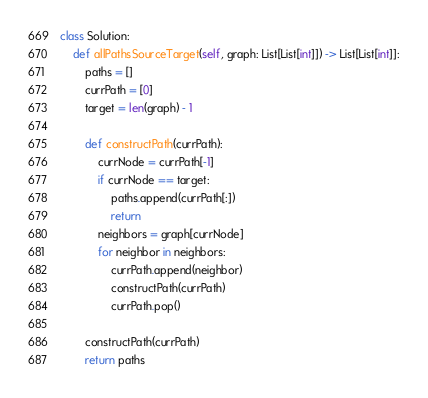Convert code to text. <code><loc_0><loc_0><loc_500><loc_500><_Python_>class Solution:
    def allPathsSourceTarget(self, graph: List[List[int]]) -> List[List[int]]:
        paths = []
        currPath = [0]
        target = len(graph) - 1
        
        def constructPath(currPath):
            currNode = currPath[-1]
            if currNode == target:
                paths.append(currPath[:])
                return
            neighbors = graph[currNode]
            for neighbor in neighbors:
                currPath.append(neighbor)
                constructPath(currPath)
                currPath.pop()

        constructPath(currPath)
        return paths
</code> 